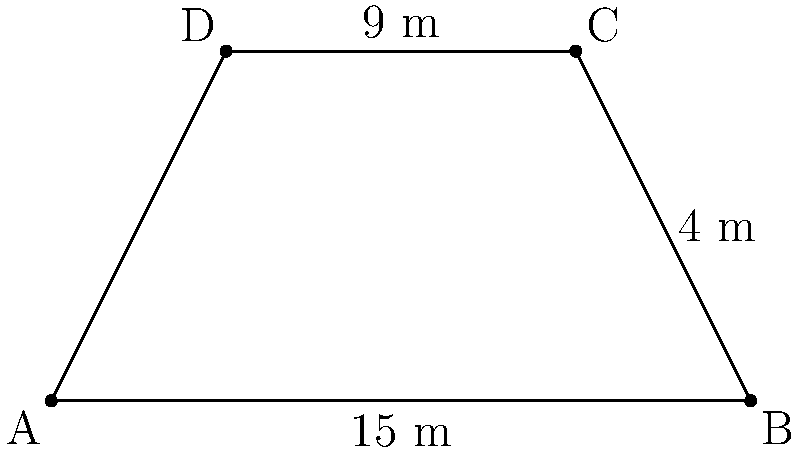At a comedy club, the stage is shaped like a trapezoid. The bottom base of the stage is 15 meters, the top base is 9 meters, and the height is 4 meters. What is the area of this comedy stage in square meters? To find the area of a trapezoid, we use the formula:

$$A = \frac{1}{2}(b_1 + b_2)h$$

Where:
$A$ = Area
$b_1$ = Length of one parallel side
$b_2$ = Length of the other parallel side
$h$ = Height (perpendicular distance between the parallel sides)

Given:
$b_1 = 15$ m (bottom base)
$b_2 = 9$ m (top base)
$h = 4$ m (height)

Let's substitute these values into the formula:

$$A = \frac{1}{2}(15 + 9) \times 4$$

$$A = \frac{1}{2}(24) \times 4$$

$$A = 12 \times 4$$

$$A = 48$$

Therefore, the area of the comedy stage is 48 square meters.
Answer: 48 m² 